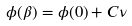<formula> <loc_0><loc_0><loc_500><loc_500>\phi ( \beta ) = \phi ( 0 ) + C \nu</formula> 